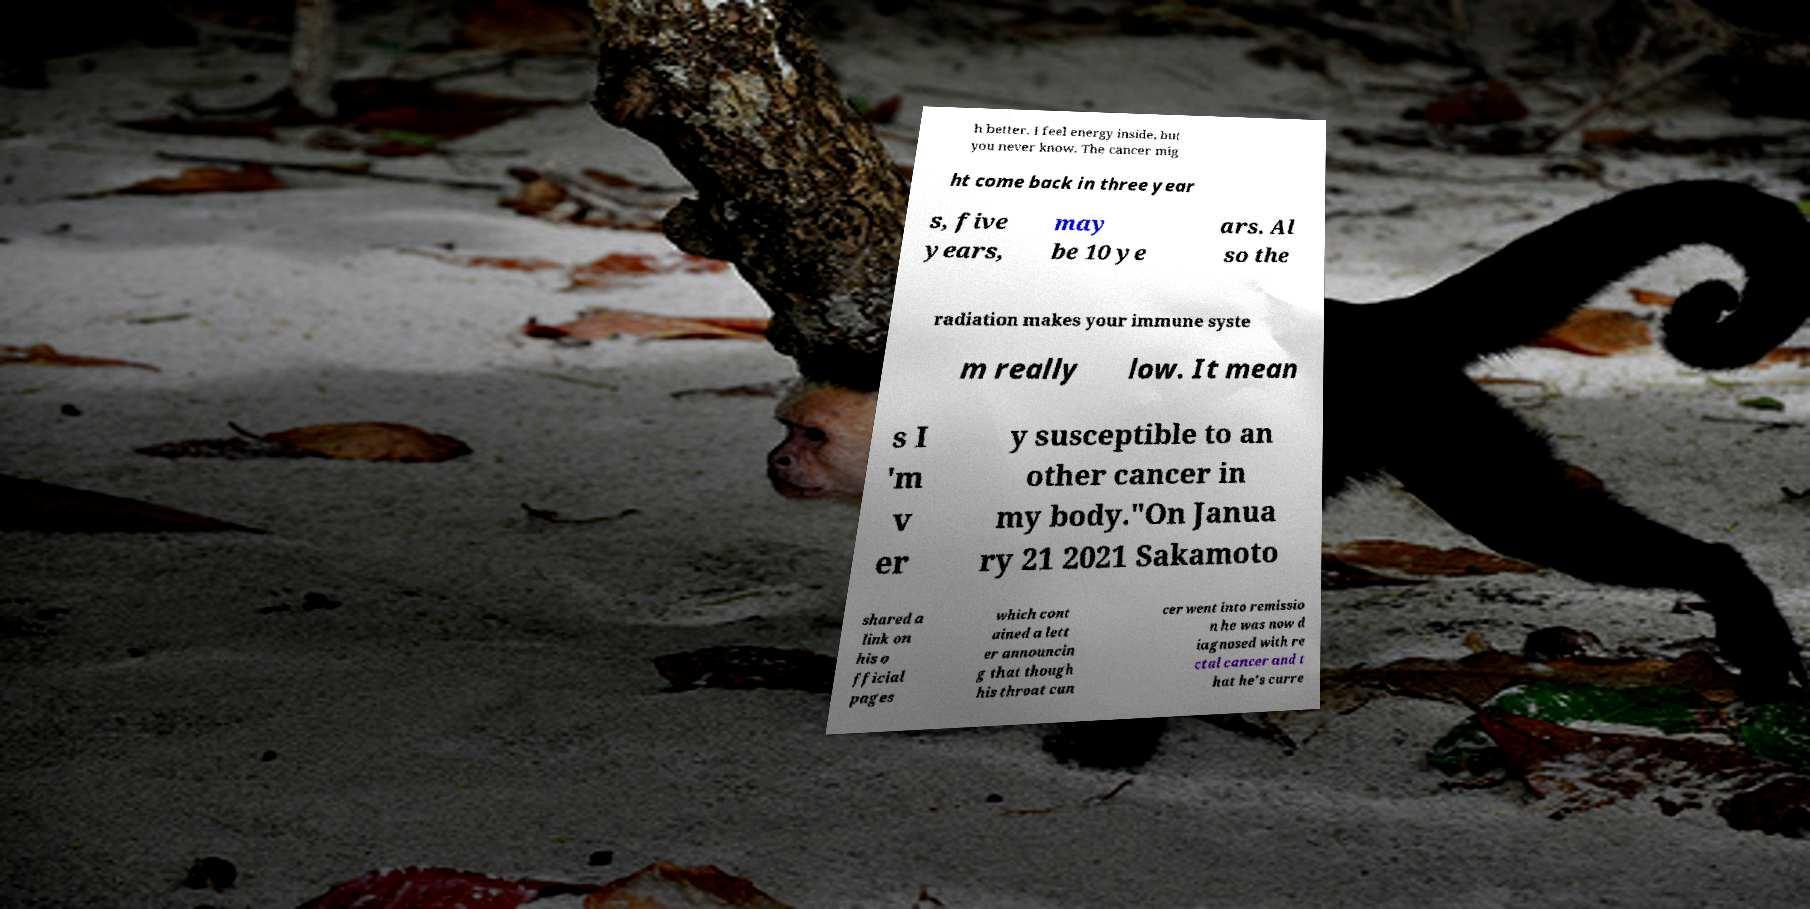For documentation purposes, I need the text within this image transcribed. Could you provide that? h better. I feel energy inside, but you never know. The cancer mig ht come back in three year s, five years, may be 10 ye ars. Al so the radiation makes your immune syste m really low. It mean s I 'm v er y susceptible to an other cancer in my body."On Janua ry 21 2021 Sakamoto shared a link on his o fficial pages which cont ained a lett er announcin g that though his throat can cer went into remissio n he was now d iagnosed with re ctal cancer and t hat he's curre 